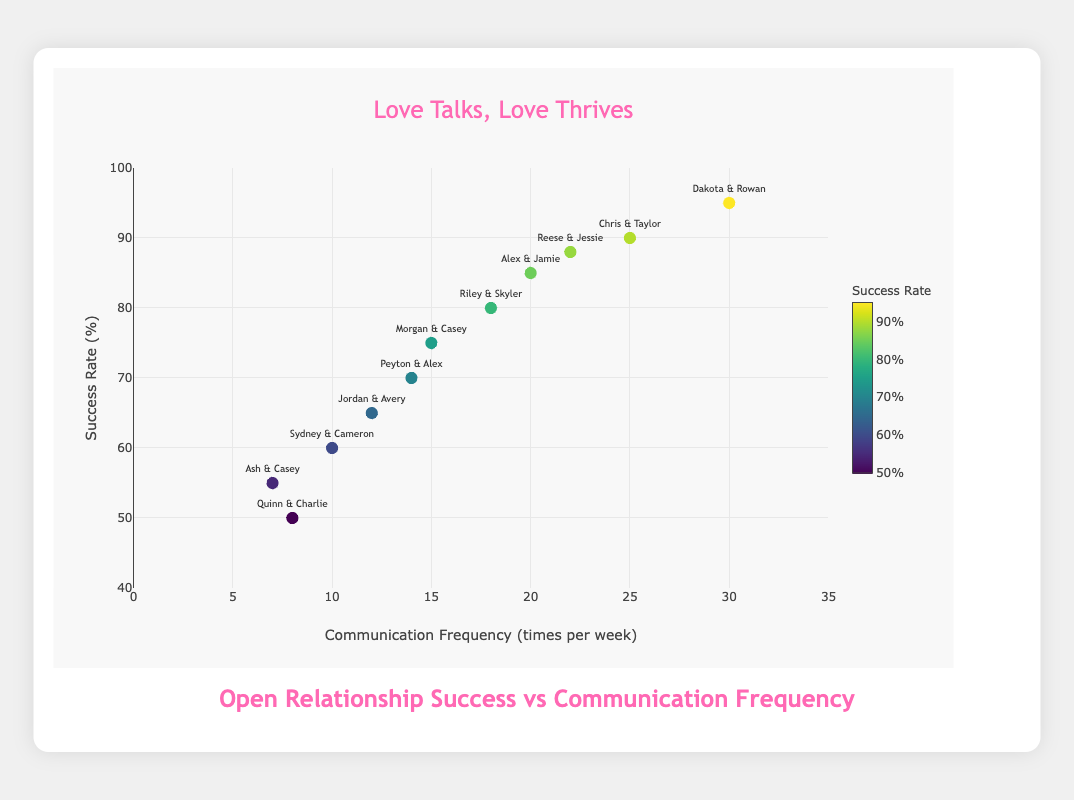What's the title of the figure? The title of the figure is displayed at the top center and reads "Love Talks, Love Thrives".
Answer: Love Talks, Love Thrives What's the range for the y-axis? The range of the y-axis is indicated by the values at the bottom and top of the axis. It goes from 40 to 100.
Answer: 40 to 100 How many data points represent a weekly communication frequency of fewer than 10 times? By counting the data points with Communication Frequency values less than 10, we identify:
- Quinn & Charlie (8)
- Ash & Casey (7)
Hence, there are 2 such data points.
Answer: 2 What couple has the highest success rate, and what is that rate? The highest success rate is indicated by the top-most data point. The couple is Dakota & Rowan with a success rate of 95%.
Answer: Dakota & Rowan, 95% Which couple has the lowest communication frequency, and what is that frequency? The lowest communication frequency is identified by the data point furthest to the left on the x-axis. The couple is Ash & Casey with a frequency of 7 times per week.
Answer: Ash & Casey, 7 Which couple is represented by the data point with a success rate of 65%? The success rate of 65% corresponds to the data point labeled "Jordan & Avery".
Answer: Jordan & Avery Is there a positive correlation between communication frequency and success rate? Observing the trend in the scatter plot, data points generally tend to increase in Success Rate as Communication Frequency increases, indicating a positive correlation.
Answer: Yes Do any couples have the same success rate? By examining all y-axis values (Success Rates) for duplicates, we find no couples sharing the exact same success rate.
Answer: No 